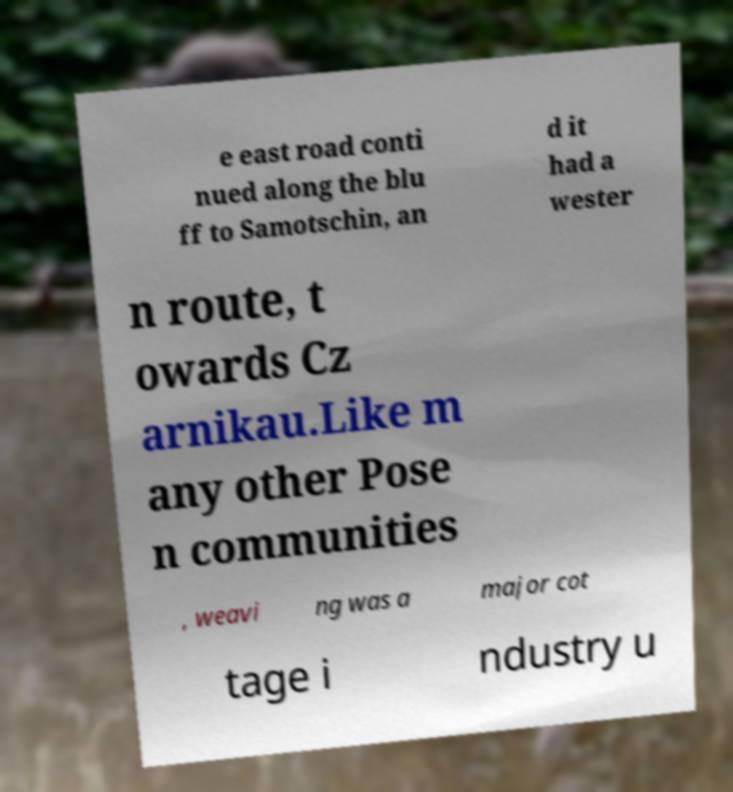I need the written content from this picture converted into text. Can you do that? e east road conti nued along the blu ff to Samotschin, an d it had a wester n route, t owards Cz arnikau.Like m any other Pose n communities , weavi ng was a major cot tage i ndustry u 